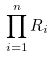Convert formula to latex. <formula><loc_0><loc_0><loc_500><loc_500>\prod _ { i = 1 } ^ { n } R _ { i }</formula> 